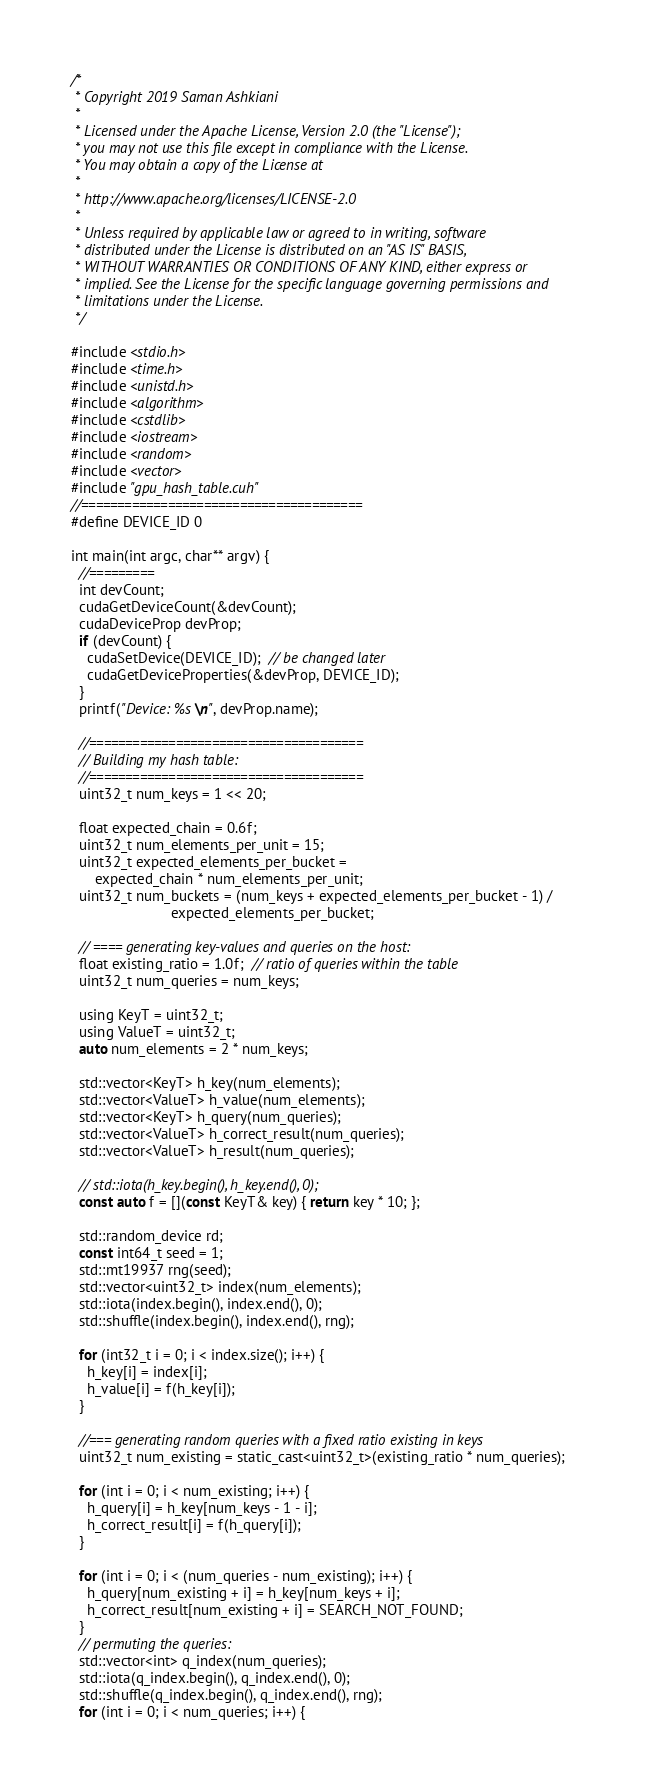<code> <loc_0><loc_0><loc_500><loc_500><_Cuda_>/*
 * Copyright 2019 Saman Ashkiani
 *
 * Licensed under the Apache License, Version 2.0 (the "License");
 * you may not use this file except in compliance with the License.
 * You may obtain a copy of the License at
 *
 * http://www.apache.org/licenses/LICENSE-2.0
 *
 * Unless required by applicable law or agreed to in writing, software
 * distributed under the License is distributed on an "AS IS" BASIS,
 * WITHOUT WARRANTIES OR CONDITIONS OF ANY KIND, either express or
 * implied. See the License for the specific language governing permissions and
 * limitations under the License.
 */

#include <stdio.h>
#include <time.h>
#include <unistd.h>
#include <algorithm>
#include <cstdlib>
#include <iostream>
#include <random>
#include <vector>
#include "gpu_hash_table.cuh"
//=======================================
#define DEVICE_ID 0

int main(int argc, char** argv) {
  //=========
  int devCount;
  cudaGetDeviceCount(&devCount);
  cudaDeviceProp devProp;
  if (devCount) {
    cudaSetDevice(DEVICE_ID);  // be changed later
    cudaGetDeviceProperties(&devProp, DEVICE_ID);
  }
  printf("Device: %s\n", devProp.name);

  //======================================
  // Building my hash table:
  //======================================
  uint32_t num_keys = 1 << 20;

  float expected_chain = 0.6f;
  uint32_t num_elements_per_unit = 15;
  uint32_t expected_elements_per_bucket =
      expected_chain * num_elements_per_unit;
  uint32_t num_buckets = (num_keys + expected_elements_per_bucket - 1) /
                         expected_elements_per_bucket;

  // ==== generating key-values and queries on the host:
  float existing_ratio = 1.0f;  // ratio of queries within the table
  uint32_t num_queries = num_keys;

  using KeyT = uint32_t;
  using ValueT = uint32_t;
  auto num_elements = 2 * num_keys;

  std::vector<KeyT> h_key(num_elements);
  std::vector<ValueT> h_value(num_elements);
  std::vector<KeyT> h_query(num_queries);
  std::vector<ValueT> h_correct_result(num_queries);
  std::vector<ValueT> h_result(num_queries);

  // std::iota(h_key.begin(), h_key.end(), 0);
  const auto f = [](const KeyT& key) { return key * 10; };

  std::random_device rd;
  const int64_t seed = 1;
  std::mt19937 rng(seed);
  std::vector<uint32_t> index(num_elements);
  std::iota(index.begin(), index.end(), 0);
  std::shuffle(index.begin(), index.end(), rng);

  for (int32_t i = 0; i < index.size(); i++) {
    h_key[i] = index[i];
    h_value[i] = f(h_key[i]);
  }

  //=== generating random queries with a fixed ratio existing in keys
  uint32_t num_existing = static_cast<uint32_t>(existing_ratio * num_queries);

  for (int i = 0; i < num_existing; i++) {
    h_query[i] = h_key[num_keys - 1 - i];
    h_correct_result[i] = f(h_query[i]);
  }

  for (int i = 0; i < (num_queries - num_existing); i++) {
    h_query[num_existing + i] = h_key[num_keys + i];
    h_correct_result[num_existing + i] = SEARCH_NOT_FOUND;
  }
  // permuting the queries:
  std::vector<int> q_index(num_queries);
  std::iota(q_index.begin(), q_index.end(), 0);
  std::shuffle(q_index.begin(), q_index.end(), rng);
  for (int i = 0; i < num_queries; i++) {</code> 